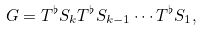Convert formula to latex. <formula><loc_0><loc_0><loc_500><loc_500>G = T ^ { \flat } S _ { k } T ^ { \flat } S _ { k - 1 } \cdots T ^ { \flat } S _ { 1 } ,</formula> 